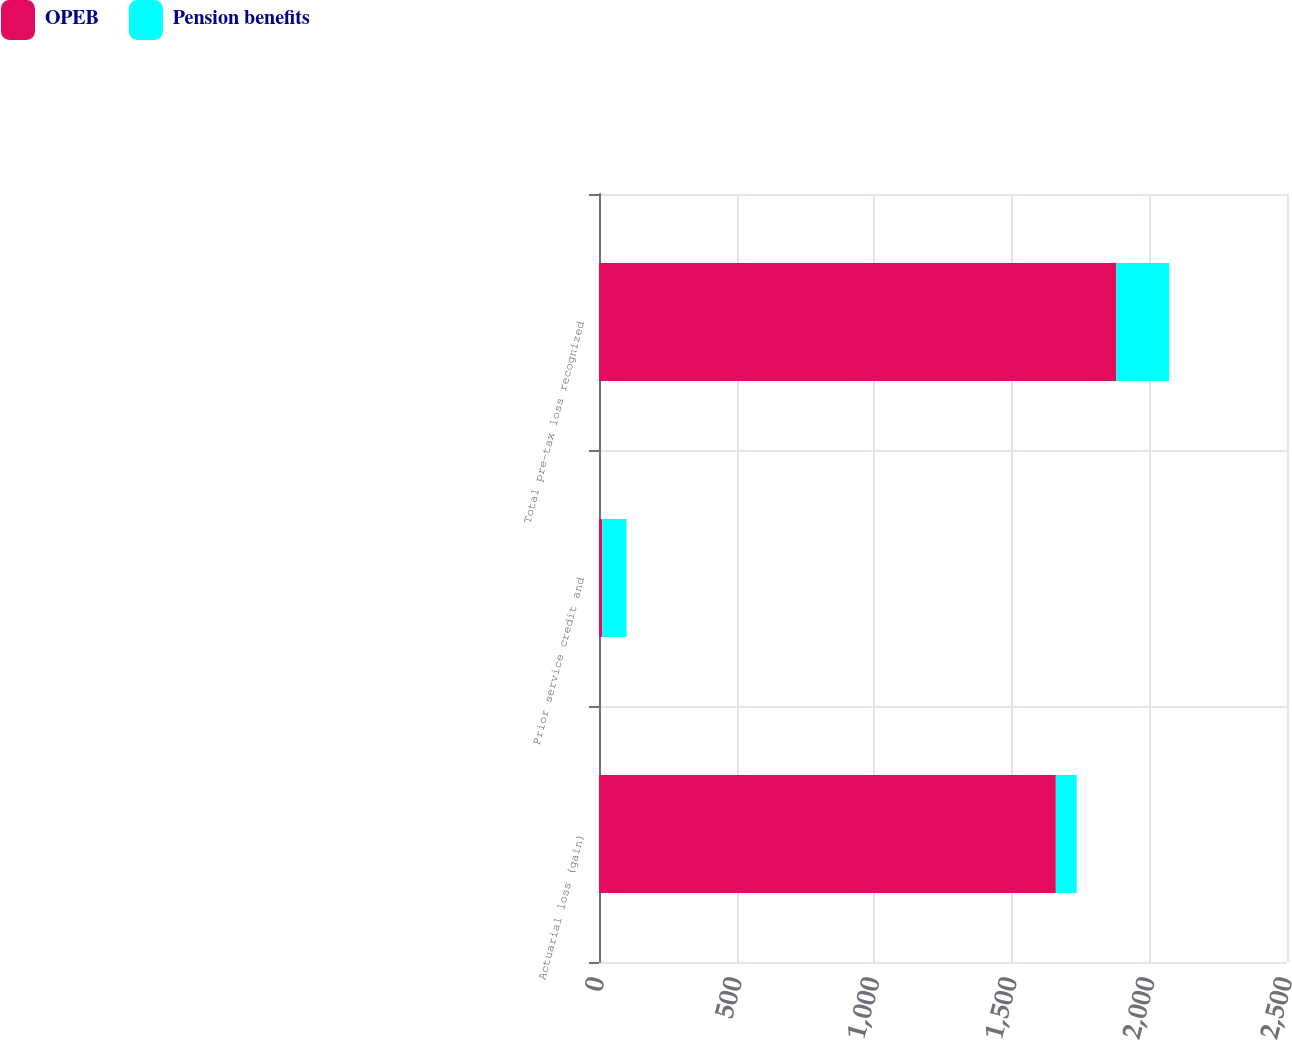<chart> <loc_0><loc_0><loc_500><loc_500><stacked_bar_chart><ecel><fcel>Actuarial loss (gain)<fcel>Prior service credit and<fcel>Total pre-tax loss recognized<nl><fcel>OPEB<fcel>1660<fcel>12<fcel>1880<nl><fcel>Pension benefits<fcel>76<fcel>88<fcel>192<nl></chart> 